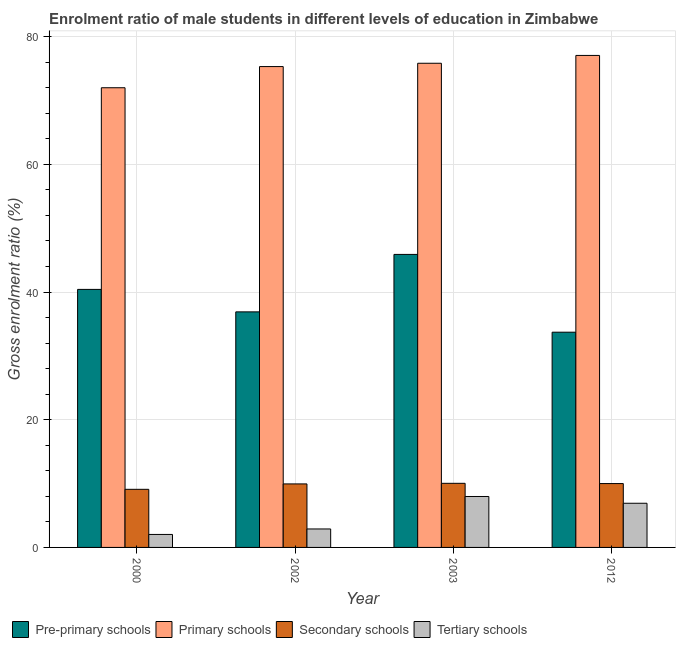How many different coloured bars are there?
Offer a terse response. 4. Are the number of bars per tick equal to the number of legend labels?
Ensure brevity in your answer.  Yes. Are the number of bars on each tick of the X-axis equal?
Provide a short and direct response. Yes. What is the label of the 3rd group of bars from the left?
Your answer should be compact. 2003. In how many cases, is the number of bars for a given year not equal to the number of legend labels?
Provide a short and direct response. 0. What is the gross enrolment ratio(female) in pre-primary schools in 2000?
Provide a short and direct response. 40.42. Across all years, what is the maximum gross enrolment ratio(female) in primary schools?
Keep it short and to the point. 77.06. Across all years, what is the minimum gross enrolment ratio(female) in primary schools?
Provide a succinct answer. 72. What is the total gross enrolment ratio(female) in primary schools in the graph?
Keep it short and to the point. 300.22. What is the difference between the gross enrolment ratio(female) in primary schools in 2000 and that in 2012?
Give a very brief answer. -5.06. What is the difference between the gross enrolment ratio(female) in tertiary schools in 2003 and the gross enrolment ratio(female) in secondary schools in 2002?
Provide a short and direct response. 5.09. What is the average gross enrolment ratio(female) in secondary schools per year?
Offer a terse response. 9.77. In the year 2012, what is the difference between the gross enrolment ratio(female) in pre-primary schools and gross enrolment ratio(female) in secondary schools?
Keep it short and to the point. 0. In how many years, is the gross enrolment ratio(female) in primary schools greater than 52 %?
Ensure brevity in your answer.  4. What is the ratio of the gross enrolment ratio(female) in tertiary schools in 2002 to that in 2012?
Make the answer very short. 0.42. Is the difference between the gross enrolment ratio(female) in pre-primary schools in 2000 and 2002 greater than the difference between the gross enrolment ratio(female) in primary schools in 2000 and 2002?
Provide a succinct answer. No. What is the difference between the highest and the second highest gross enrolment ratio(female) in pre-primary schools?
Keep it short and to the point. 5.48. What is the difference between the highest and the lowest gross enrolment ratio(female) in tertiary schools?
Keep it short and to the point. 5.94. In how many years, is the gross enrolment ratio(female) in primary schools greater than the average gross enrolment ratio(female) in primary schools taken over all years?
Provide a succinct answer. 3. Is the sum of the gross enrolment ratio(female) in secondary schools in 2002 and 2012 greater than the maximum gross enrolment ratio(female) in primary schools across all years?
Keep it short and to the point. Yes. What does the 4th bar from the left in 2002 represents?
Make the answer very short. Tertiary schools. What does the 1st bar from the right in 2003 represents?
Your answer should be very brief. Tertiary schools. How many bars are there?
Your answer should be compact. 16. Are all the bars in the graph horizontal?
Your answer should be compact. No. Are the values on the major ticks of Y-axis written in scientific E-notation?
Your answer should be compact. No. Does the graph contain any zero values?
Provide a succinct answer. No. How many legend labels are there?
Ensure brevity in your answer.  4. How are the legend labels stacked?
Keep it short and to the point. Horizontal. What is the title of the graph?
Offer a very short reply. Enrolment ratio of male students in different levels of education in Zimbabwe. Does "Labor Taxes" appear as one of the legend labels in the graph?
Your response must be concise. No. What is the label or title of the Y-axis?
Ensure brevity in your answer.  Gross enrolment ratio (%). What is the Gross enrolment ratio (%) of Pre-primary schools in 2000?
Your answer should be very brief. 40.42. What is the Gross enrolment ratio (%) in Primary schools in 2000?
Offer a terse response. 72. What is the Gross enrolment ratio (%) of Secondary schools in 2000?
Keep it short and to the point. 9.1. What is the Gross enrolment ratio (%) in Tertiary schools in 2000?
Offer a terse response. 2.03. What is the Gross enrolment ratio (%) in Pre-primary schools in 2002?
Offer a very short reply. 36.9. What is the Gross enrolment ratio (%) in Primary schools in 2002?
Keep it short and to the point. 75.32. What is the Gross enrolment ratio (%) of Secondary schools in 2002?
Your answer should be very brief. 9.95. What is the Gross enrolment ratio (%) of Tertiary schools in 2002?
Offer a very short reply. 2.89. What is the Gross enrolment ratio (%) in Pre-primary schools in 2003?
Ensure brevity in your answer.  45.9. What is the Gross enrolment ratio (%) of Primary schools in 2003?
Your answer should be compact. 75.84. What is the Gross enrolment ratio (%) of Secondary schools in 2003?
Give a very brief answer. 10.04. What is the Gross enrolment ratio (%) of Tertiary schools in 2003?
Ensure brevity in your answer.  7.98. What is the Gross enrolment ratio (%) in Pre-primary schools in 2012?
Keep it short and to the point. 33.71. What is the Gross enrolment ratio (%) of Primary schools in 2012?
Provide a succinct answer. 77.06. What is the Gross enrolment ratio (%) in Secondary schools in 2012?
Your response must be concise. 10. What is the Gross enrolment ratio (%) of Tertiary schools in 2012?
Ensure brevity in your answer.  6.92. Across all years, what is the maximum Gross enrolment ratio (%) of Pre-primary schools?
Make the answer very short. 45.9. Across all years, what is the maximum Gross enrolment ratio (%) of Primary schools?
Your response must be concise. 77.06. Across all years, what is the maximum Gross enrolment ratio (%) in Secondary schools?
Your answer should be compact. 10.04. Across all years, what is the maximum Gross enrolment ratio (%) in Tertiary schools?
Provide a succinct answer. 7.98. Across all years, what is the minimum Gross enrolment ratio (%) of Pre-primary schools?
Make the answer very short. 33.71. Across all years, what is the minimum Gross enrolment ratio (%) of Primary schools?
Give a very brief answer. 72. Across all years, what is the minimum Gross enrolment ratio (%) in Secondary schools?
Give a very brief answer. 9.1. Across all years, what is the minimum Gross enrolment ratio (%) of Tertiary schools?
Give a very brief answer. 2.03. What is the total Gross enrolment ratio (%) of Pre-primary schools in the graph?
Offer a terse response. 156.92. What is the total Gross enrolment ratio (%) in Primary schools in the graph?
Your answer should be compact. 300.22. What is the total Gross enrolment ratio (%) of Secondary schools in the graph?
Offer a very short reply. 39.09. What is the total Gross enrolment ratio (%) of Tertiary schools in the graph?
Provide a succinct answer. 19.82. What is the difference between the Gross enrolment ratio (%) of Pre-primary schools in 2000 and that in 2002?
Your answer should be compact. 3.52. What is the difference between the Gross enrolment ratio (%) of Primary schools in 2000 and that in 2002?
Your answer should be very brief. -3.32. What is the difference between the Gross enrolment ratio (%) of Secondary schools in 2000 and that in 2002?
Make the answer very short. -0.85. What is the difference between the Gross enrolment ratio (%) in Tertiary schools in 2000 and that in 2002?
Your answer should be compact. -0.86. What is the difference between the Gross enrolment ratio (%) of Pre-primary schools in 2000 and that in 2003?
Provide a short and direct response. -5.48. What is the difference between the Gross enrolment ratio (%) of Primary schools in 2000 and that in 2003?
Give a very brief answer. -3.84. What is the difference between the Gross enrolment ratio (%) of Secondary schools in 2000 and that in 2003?
Make the answer very short. -0.94. What is the difference between the Gross enrolment ratio (%) in Tertiary schools in 2000 and that in 2003?
Offer a terse response. -5.94. What is the difference between the Gross enrolment ratio (%) of Pre-primary schools in 2000 and that in 2012?
Offer a very short reply. 6.7. What is the difference between the Gross enrolment ratio (%) of Primary schools in 2000 and that in 2012?
Offer a very short reply. -5.06. What is the difference between the Gross enrolment ratio (%) in Secondary schools in 2000 and that in 2012?
Your response must be concise. -0.9. What is the difference between the Gross enrolment ratio (%) of Tertiary schools in 2000 and that in 2012?
Your answer should be very brief. -4.88. What is the difference between the Gross enrolment ratio (%) in Pre-primary schools in 2002 and that in 2003?
Your answer should be very brief. -9. What is the difference between the Gross enrolment ratio (%) in Primary schools in 2002 and that in 2003?
Ensure brevity in your answer.  -0.52. What is the difference between the Gross enrolment ratio (%) in Secondary schools in 2002 and that in 2003?
Provide a succinct answer. -0.09. What is the difference between the Gross enrolment ratio (%) in Tertiary schools in 2002 and that in 2003?
Offer a terse response. -5.09. What is the difference between the Gross enrolment ratio (%) of Pre-primary schools in 2002 and that in 2012?
Provide a succinct answer. 3.18. What is the difference between the Gross enrolment ratio (%) in Primary schools in 2002 and that in 2012?
Provide a succinct answer. -1.74. What is the difference between the Gross enrolment ratio (%) in Secondary schools in 2002 and that in 2012?
Keep it short and to the point. -0.06. What is the difference between the Gross enrolment ratio (%) in Tertiary schools in 2002 and that in 2012?
Provide a short and direct response. -4.03. What is the difference between the Gross enrolment ratio (%) of Pre-primary schools in 2003 and that in 2012?
Ensure brevity in your answer.  12.18. What is the difference between the Gross enrolment ratio (%) in Primary schools in 2003 and that in 2012?
Your answer should be compact. -1.23. What is the difference between the Gross enrolment ratio (%) of Secondary schools in 2003 and that in 2012?
Ensure brevity in your answer.  0.04. What is the difference between the Gross enrolment ratio (%) in Tertiary schools in 2003 and that in 2012?
Offer a very short reply. 1.06. What is the difference between the Gross enrolment ratio (%) of Pre-primary schools in 2000 and the Gross enrolment ratio (%) of Primary schools in 2002?
Provide a succinct answer. -34.9. What is the difference between the Gross enrolment ratio (%) in Pre-primary schools in 2000 and the Gross enrolment ratio (%) in Secondary schools in 2002?
Your answer should be compact. 30.47. What is the difference between the Gross enrolment ratio (%) in Pre-primary schools in 2000 and the Gross enrolment ratio (%) in Tertiary schools in 2002?
Your response must be concise. 37.52. What is the difference between the Gross enrolment ratio (%) of Primary schools in 2000 and the Gross enrolment ratio (%) of Secondary schools in 2002?
Offer a very short reply. 62.05. What is the difference between the Gross enrolment ratio (%) in Primary schools in 2000 and the Gross enrolment ratio (%) in Tertiary schools in 2002?
Your answer should be compact. 69.11. What is the difference between the Gross enrolment ratio (%) in Secondary schools in 2000 and the Gross enrolment ratio (%) in Tertiary schools in 2002?
Provide a succinct answer. 6.21. What is the difference between the Gross enrolment ratio (%) in Pre-primary schools in 2000 and the Gross enrolment ratio (%) in Primary schools in 2003?
Keep it short and to the point. -35.42. What is the difference between the Gross enrolment ratio (%) in Pre-primary schools in 2000 and the Gross enrolment ratio (%) in Secondary schools in 2003?
Your answer should be very brief. 30.37. What is the difference between the Gross enrolment ratio (%) in Pre-primary schools in 2000 and the Gross enrolment ratio (%) in Tertiary schools in 2003?
Your answer should be very brief. 32.44. What is the difference between the Gross enrolment ratio (%) in Primary schools in 2000 and the Gross enrolment ratio (%) in Secondary schools in 2003?
Your response must be concise. 61.96. What is the difference between the Gross enrolment ratio (%) in Primary schools in 2000 and the Gross enrolment ratio (%) in Tertiary schools in 2003?
Offer a very short reply. 64.02. What is the difference between the Gross enrolment ratio (%) in Secondary schools in 2000 and the Gross enrolment ratio (%) in Tertiary schools in 2003?
Offer a very short reply. 1.12. What is the difference between the Gross enrolment ratio (%) of Pre-primary schools in 2000 and the Gross enrolment ratio (%) of Primary schools in 2012?
Your answer should be compact. -36.65. What is the difference between the Gross enrolment ratio (%) in Pre-primary schools in 2000 and the Gross enrolment ratio (%) in Secondary schools in 2012?
Provide a short and direct response. 30.41. What is the difference between the Gross enrolment ratio (%) in Pre-primary schools in 2000 and the Gross enrolment ratio (%) in Tertiary schools in 2012?
Your answer should be compact. 33.5. What is the difference between the Gross enrolment ratio (%) in Primary schools in 2000 and the Gross enrolment ratio (%) in Secondary schools in 2012?
Offer a terse response. 62. What is the difference between the Gross enrolment ratio (%) of Primary schools in 2000 and the Gross enrolment ratio (%) of Tertiary schools in 2012?
Give a very brief answer. 65.08. What is the difference between the Gross enrolment ratio (%) in Secondary schools in 2000 and the Gross enrolment ratio (%) in Tertiary schools in 2012?
Keep it short and to the point. 2.18. What is the difference between the Gross enrolment ratio (%) of Pre-primary schools in 2002 and the Gross enrolment ratio (%) of Primary schools in 2003?
Keep it short and to the point. -38.94. What is the difference between the Gross enrolment ratio (%) in Pre-primary schools in 2002 and the Gross enrolment ratio (%) in Secondary schools in 2003?
Make the answer very short. 26.86. What is the difference between the Gross enrolment ratio (%) of Pre-primary schools in 2002 and the Gross enrolment ratio (%) of Tertiary schools in 2003?
Offer a very short reply. 28.92. What is the difference between the Gross enrolment ratio (%) in Primary schools in 2002 and the Gross enrolment ratio (%) in Secondary schools in 2003?
Ensure brevity in your answer.  65.28. What is the difference between the Gross enrolment ratio (%) of Primary schools in 2002 and the Gross enrolment ratio (%) of Tertiary schools in 2003?
Ensure brevity in your answer.  67.34. What is the difference between the Gross enrolment ratio (%) of Secondary schools in 2002 and the Gross enrolment ratio (%) of Tertiary schools in 2003?
Your response must be concise. 1.97. What is the difference between the Gross enrolment ratio (%) in Pre-primary schools in 2002 and the Gross enrolment ratio (%) in Primary schools in 2012?
Offer a very short reply. -40.17. What is the difference between the Gross enrolment ratio (%) of Pre-primary schools in 2002 and the Gross enrolment ratio (%) of Secondary schools in 2012?
Ensure brevity in your answer.  26.89. What is the difference between the Gross enrolment ratio (%) of Pre-primary schools in 2002 and the Gross enrolment ratio (%) of Tertiary schools in 2012?
Make the answer very short. 29.98. What is the difference between the Gross enrolment ratio (%) in Primary schools in 2002 and the Gross enrolment ratio (%) in Secondary schools in 2012?
Your answer should be compact. 65.32. What is the difference between the Gross enrolment ratio (%) of Primary schools in 2002 and the Gross enrolment ratio (%) of Tertiary schools in 2012?
Keep it short and to the point. 68.4. What is the difference between the Gross enrolment ratio (%) in Secondary schools in 2002 and the Gross enrolment ratio (%) in Tertiary schools in 2012?
Ensure brevity in your answer.  3.03. What is the difference between the Gross enrolment ratio (%) in Pre-primary schools in 2003 and the Gross enrolment ratio (%) in Primary schools in 2012?
Your response must be concise. -31.17. What is the difference between the Gross enrolment ratio (%) in Pre-primary schools in 2003 and the Gross enrolment ratio (%) in Secondary schools in 2012?
Your answer should be compact. 35.89. What is the difference between the Gross enrolment ratio (%) of Pre-primary schools in 2003 and the Gross enrolment ratio (%) of Tertiary schools in 2012?
Provide a succinct answer. 38.98. What is the difference between the Gross enrolment ratio (%) of Primary schools in 2003 and the Gross enrolment ratio (%) of Secondary schools in 2012?
Your answer should be compact. 65.83. What is the difference between the Gross enrolment ratio (%) in Primary schools in 2003 and the Gross enrolment ratio (%) in Tertiary schools in 2012?
Provide a succinct answer. 68.92. What is the difference between the Gross enrolment ratio (%) in Secondary schools in 2003 and the Gross enrolment ratio (%) in Tertiary schools in 2012?
Provide a succinct answer. 3.12. What is the average Gross enrolment ratio (%) of Pre-primary schools per year?
Ensure brevity in your answer.  39.23. What is the average Gross enrolment ratio (%) in Primary schools per year?
Make the answer very short. 75.06. What is the average Gross enrolment ratio (%) in Secondary schools per year?
Give a very brief answer. 9.77. What is the average Gross enrolment ratio (%) of Tertiary schools per year?
Offer a terse response. 4.95. In the year 2000, what is the difference between the Gross enrolment ratio (%) in Pre-primary schools and Gross enrolment ratio (%) in Primary schools?
Your answer should be compact. -31.59. In the year 2000, what is the difference between the Gross enrolment ratio (%) in Pre-primary schools and Gross enrolment ratio (%) in Secondary schools?
Ensure brevity in your answer.  31.31. In the year 2000, what is the difference between the Gross enrolment ratio (%) of Pre-primary schools and Gross enrolment ratio (%) of Tertiary schools?
Provide a succinct answer. 38.38. In the year 2000, what is the difference between the Gross enrolment ratio (%) in Primary schools and Gross enrolment ratio (%) in Secondary schools?
Give a very brief answer. 62.9. In the year 2000, what is the difference between the Gross enrolment ratio (%) of Primary schools and Gross enrolment ratio (%) of Tertiary schools?
Make the answer very short. 69.97. In the year 2000, what is the difference between the Gross enrolment ratio (%) in Secondary schools and Gross enrolment ratio (%) in Tertiary schools?
Give a very brief answer. 7.07. In the year 2002, what is the difference between the Gross enrolment ratio (%) in Pre-primary schools and Gross enrolment ratio (%) in Primary schools?
Offer a terse response. -38.42. In the year 2002, what is the difference between the Gross enrolment ratio (%) in Pre-primary schools and Gross enrolment ratio (%) in Secondary schools?
Your answer should be very brief. 26.95. In the year 2002, what is the difference between the Gross enrolment ratio (%) in Pre-primary schools and Gross enrolment ratio (%) in Tertiary schools?
Your response must be concise. 34.01. In the year 2002, what is the difference between the Gross enrolment ratio (%) in Primary schools and Gross enrolment ratio (%) in Secondary schools?
Give a very brief answer. 65.37. In the year 2002, what is the difference between the Gross enrolment ratio (%) of Primary schools and Gross enrolment ratio (%) of Tertiary schools?
Provide a short and direct response. 72.43. In the year 2002, what is the difference between the Gross enrolment ratio (%) in Secondary schools and Gross enrolment ratio (%) in Tertiary schools?
Your answer should be very brief. 7.06. In the year 2003, what is the difference between the Gross enrolment ratio (%) of Pre-primary schools and Gross enrolment ratio (%) of Primary schools?
Ensure brevity in your answer.  -29.94. In the year 2003, what is the difference between the Gross enrolment ratio (%) in Pre-primary schools and Gross enrolment ratio (%) in Secondary schools?
Provide a succinct answer. 35.85. In the year 2003, what is the difference between the Gross enrolment ratio (%) of Pre-primary schools and Gross enrolment ratio (%) of Tertiary schools?
Provide a succinct answer. 37.92. In the year 2003, what is the difference between the Gross enrolment ratio (%) of Primary schools and Gross enrolment ratio (%) of Secondary schools?
Ensure brevity in your answer.  65.8. In the year 2003, what is the difference between the Gross enrolment ratio (%) in Primary schools and Gross enrolment ratio (%) in Tertiary schools?
Offer a terse response. 67.86. In the year 2003, what is the difference between the Gross enrolment ratio (%) in Secondary schools and Gross enrolment ratio (%) in Tertiary schools?
Your answer should be compact. 2.06. In the year 2012, what is the difference between the Gross enrolment ratio (%) in Pre-primary schools and Gross enrolment ratio (%) in Primary schools?
Ensure brevity in your answer.  -43.35. In the year 2012, what is the difference between the Gross enrolment ratio (%) in Pre-primary schools and Gross enrolment ratio (%) in Secondary schools?
Make the answer very short. 23.71. In the year 2012, what is the difference between the Gross enrolment ratio (%) of Pre-primary schools and Gross enrolment ratio (%) of Tertiary schools?
Give a very brief answer. 26.8. In the year 2012, what is the difference between the Gross enrolment ratio (%) of Primary schools and Gross enrolment ratio (%) of Secondary schools?
Provide a succinct answer. 67.06. In the year 2012, what is the difference between the Gross enrolment ratio (%) of Primary schools and Gross enrolment ratio (%) of Tertiary schools?
Give a very brief answer. 70.15. In the year 2012, what is the difference between the Gross enrolment ratio (%) of Secondary schools and Gross enrolment ratio (%) of Tertiary schools?
Offer a terse response. 3.09. What is the ratio of the Gross enrolment ratio (%) in Pre-primary schools in 2000 to that in 2002?
Your answer should be very brief. 1.1. What is the ratio of the Gross enrolment ratio (%) in Primary schools in 2000 to that in 2002?
Your answer should be compact. 0.96. What is the ratio of the Gross enrolment ratio (%) of Secondary schools in 2000 to that in 2002?
Give a very brief answer. 0.91. What is the ratio of the Gross enrolment ratio (%) of Tertiary schools in 2000 to that in 2002?
Provide a short and direct response. 0.7. What is the ratio of the Gross enrolment ratio (%) of Pre-primary schools in 2000 to that in 2003?
Make the answer very short. 0.88. What is the ratio of the Gross enrolment ratio (%) in Primary schools in 2000 to that in 2003?
Make the answer very short. 0.95. What is the ratio of the Gross enrolment ratio (%) in Secondary schools in 2000 to that in 2003?
Your response must be concise. 0.91. What is the ratio of the Gross enrolment ratio (%) of Tertiary schools in 2000 to that in 2003?
Keep it short and to the point. 0.25. What is the ratio of the Gross enrolment ratio (%) in Pre-primary schools in 2000 to that in 2012?
Keep it short and to the point. 1.2. What is the ratio of the Gross enrolment ratio (%) of Primary schools in 2000 to that in 2012?
Ensure brevity in your answer.  0.93. What is the ratio of the Gross enrolment ratio (%) in Secondary schools in 2000 to that in 2012?
Your answer should be compact. 0.91. What is the ratio of the Gross enrolment ratio (%) of Tertiary schools in 2000 to that in 2012?
Your answer should be very brief. 0.29. What is the ratio of the Gross enrolment ratio (%) of Pre-primary schools in 2002 to that in 2003?
Give a very brief answer. 0.8. What is the ratio of the Gross enrolment ratio (%) of Primary schools in 2002 to that in 2003?
Offer a terse response. 0.99. What is the ratio of the Gross enrolment ratio (%) of Secondary schools in 2002 to that in 2003?
Offer a terse response. 0.99. What is the ratio of the Gross enrolment ratio (%) in Tertiary schools in 2002 to that in 2003?
Your answer should be very brief. 0.36. What is the ratio of the Gross enrolment ratio (%) in Pre-primary schools in 2002 to that in 2012?
Your answer should be compact. 1.09. What is the ratio of the Gross enrolment ratio (%) of Primary schools in 2002 to that in 2012?
Your response must be concise. 0.98. What is the ratio of the Gross enrolment ratio (%) of Tertiary schools in 2002 to that in 2012?
Make the answer very short. 0.42. What is the ratio of the Gross enrolment ratio (%) of Pre-primary schools in 2003 to that in 2012?
Offer a very short reply. 1.36. What is the ratio of the Gross enrolment ratio (%) in Primary schools in 2003 to that in 2012?
Give a very brief answer. 0.98. What is the ratio of the Gross enrolment ratio (%) in Secondary schools in 2003 to that in 2012?
Provide a succinct answer. 1. What is the ratio of the Gross enrolment ratio (%) in Tertiary schools in 2003 to that in 2012?
Your response must be concise. 1.15. What is the difference between the highest and the second highest Gross enrolment ratio (%) of Pre-primary schools?
Offer a very short reply. 5.48. What is the difference between the highest and the second highest Gross enrolment ratio (%) of Primary schools?
Keep it short and to the point. 1.23. What is the difference between the highest and the second highest Gross enrolment ratio (%) of Secondary schools?
Your response must be concise. 0.04. What is the difference between the highest and the second highest Gross enrolment ratio (%) of Tertiary schools?
Your answer should be compact. 1.06. What is the difference between the highest and the lowest Gross enrolment ratio (%) of Pre-primary schools?
Make the answer very short. 12.18. What is the difference between the highest and the lowest Gross enrolment ratio (%) of Primary schools?
Provide a succinct answer. 5.06. What is the difference between the highest and the lowest Gross enrolment ratio (%) of Secondary schools?
Provide a short and direct response. 0.94. What is the difference between the highest and the lowest Gross enrolment ratio (%) in Tertiary schools?
Your answer should be compact. 5.94. 